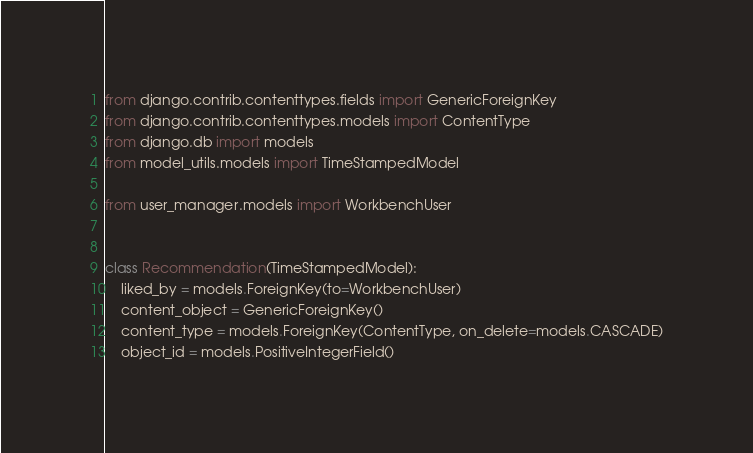Convert code to text. <code><loc_0><loc_0><loc_500><loc_500><_Python_>from django.contrib.contenttypes.fields import GenericForeignKey
from django.contrib.contenttypes.models import ContentType
from django.db import models
from model_utils.models import TimeStampedModel

from user_manager.models import WorkbenchUser


class Recommendation(TimeStampedModel):
    liked_by = models.ForeignKey(to=WorkbenchUser)
    content_object = GenericForeignKey()
    content_type = models.ForeignKey(ContentType, on_delete=models.CASCADE)
    object_id = models.PositiveIntegerField()
</code> 